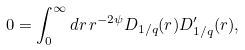<formula> <loc_0><loc_0><loc_500><loc_500>0 = \int _ { 0 } ^ { \infty } d r \, r ^ { - 2 \psi } D _ { 1 / q } ( r ) D _ { 1 / q } ^ { \prime } ( r ) ,</formula> 